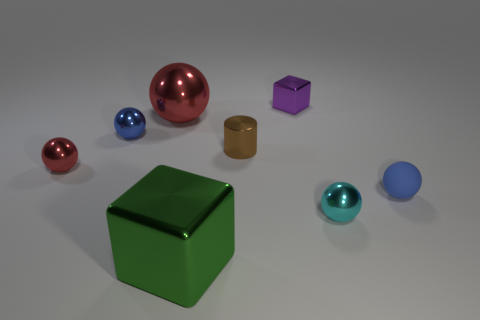There is a big ball on the left side of the small block; is it the same color as the thing on the left side of the blue metallic sphere?
Offer a terse response. Yes. What size is the metal ball that is in front of the blue thing that is right of the metal block that is in front of the tiny cyan shiny ball?
Provide a succinct answer. Small. What shape is the tiny red shiny object?
Keep it short and to the point. Sphere. What size is the shiny thing that is the same color as the matte thing?
Your answer should be compact. Small. How many red spheres are on the left side of the small shiny thing that is to the right of the purple shiny cube?
Keep it short and to the point. 2. What number of other objects are the same material as the big block?
Your response must be concise. 6. Does the small ball that is to the right of the small cyan object have the same material as the blue thing that is to the left of the cyan metallic sphere?
Your answer should be very brief. No. Are there any other things that are the same shape as the cyan thing?
Keep it short and to the point. Yes. Are the large ball and the blue ball right of the tiny cube made of the same material?
Your response must be concise. No. The metal object that is in front of the tiny metallic object to the right of the shiny block that is to the right of the brown shiny object is what color?
Offer a terse response. Green. 